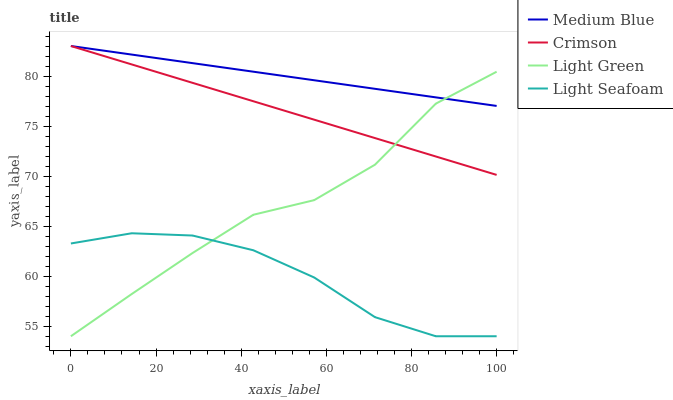Does Medium Blue have the minimum area under the curve?
Answer yes or no. No. Does Light Seafoam have the maximum area under the curve?
Answer yes or no. No. Is Light Seafoam the smoothest?
Answer yes or no. No. Is Light Seafoam the roughest?
Answer yes or no. No. Does Medium Blue have the lowest value?
Answer yes or no. No. Does Light Seafoam have the highest value?
Answer yes or no. No. Is Light Seafoam less than Medium Blue?
Answer yes or no. Yes. Is Crimson greater than Light Seafoam?
Answer yes or no. Yes. Does Light Seafoam intersect Medium Blue?
Answer yes or no. No. 